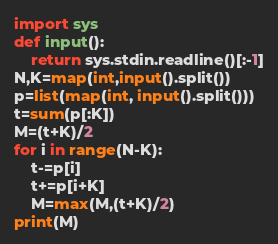Convert code to text. <code><loc_0><loc_0><loc_500><loc_500><_Python_>import sys
def input():
    return sys.stdin.readline()[:-1]
N,K=map(int,input().split())
p=list(map(int, input().split()))
t=sum(p[:K])
M=(t+K)/2
for i in range(N-K):
    t-=p[i]
    t+=p[i+K]
    M=max(M,(t+K)/2)
print(M)</code> 